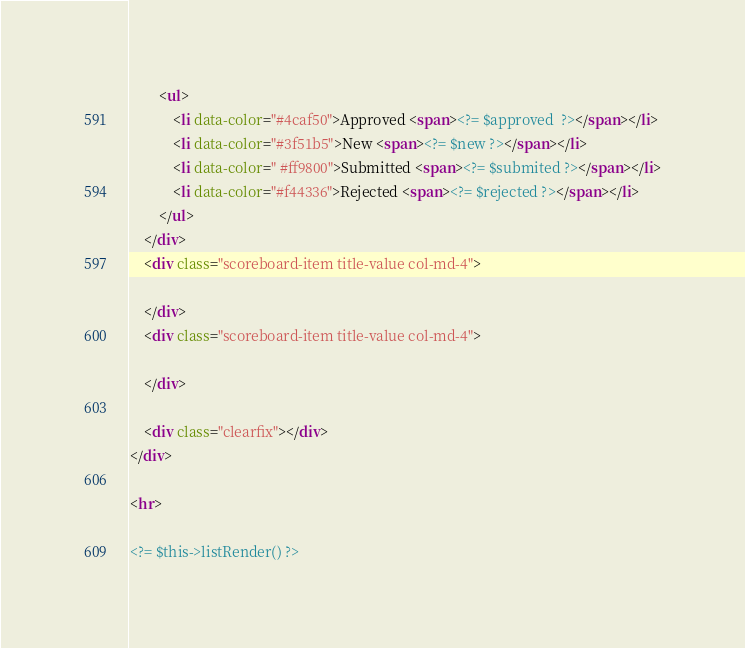Convert code to text. <code><loc_0><loc_0><loc_500><loc_500><_HTML_>        <ul>
            <li data-color="#4caf50">Approved <span><?= $approved  ?></span></li>
            <li data-color="#3f51b5">New <span><?= $new ?></span></li>
            <li data-color=" #ff9800">Submitted <span><?= $submited ?></span></li>
            <li data-color="#f44336">Rejected <span><?= $rejected ?></span></li>
        </ul>
    </div>
    <div class="scoreboard-item title-value col-md-4">
        
    </div>
    <div class="scoreboard-item title-value col-md-4">
        
    </div>    
    
    <div class="clearfix"></div>
</div>

<hr>

<?= $this->listRender() ?>
</code> 